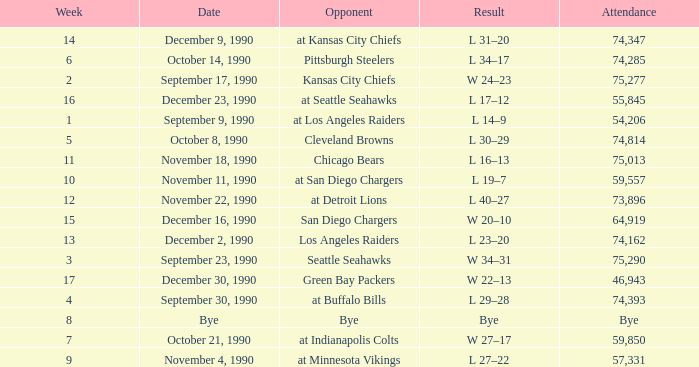What day was the attendance 74,285? October 14, 1990. 